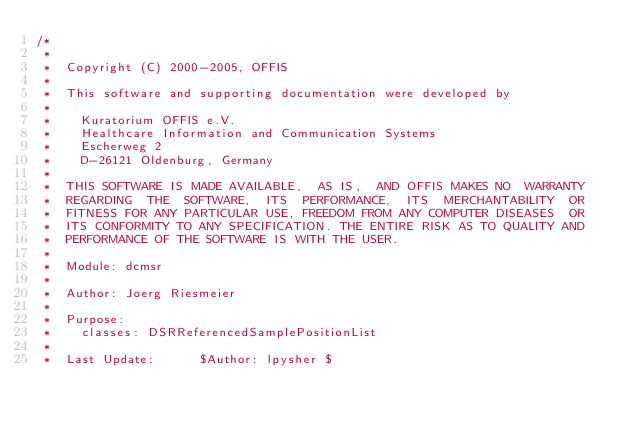Convert code to text. <code><loc_0><loc_0><loc_500><loc_500><_C_>/*
 *
 *  Copyright (C) 2000-2005, OFFIS
 *
 *  This software and supporting documentation were developed by
 *
 *    Kuratorium OFFIS e.V.
 *    Healthcare Information and Communication Systems
 *    Escherweg 2
 *    D-26121 Oldenburg, Germany
 *
 *  THIS SOFTWARE IS MADE AVAILABLE,  AS IS,  AND OFFIS MAKES NO  WARRANTY
 *  REGARDING  THE  SOFTWARE,  ITS  PERFORMANCE,  ITS  MERCHANTABILITY  OR
 *  FITNESS FOR ANY PARTICULAR USE, FREEDOM FROM ANY COMPUTER DISEASES  OR
 *  ITS CONFORMITY TO ANY SPECIFICATION. THE ENTIRE RISK AS TO QUALITY AND
 *  PERFORMANCE OF THE SOFTWARE IS WITH THE USER.
 *
 *  Module: dcmsr
 *
 *  Author: Joerg Riesmeier
 *
 *  Purpose:
 *    classes: DSRReferencedSamplePositionList
 *
 *  Last Update:      $Author: lpysher $</code> 